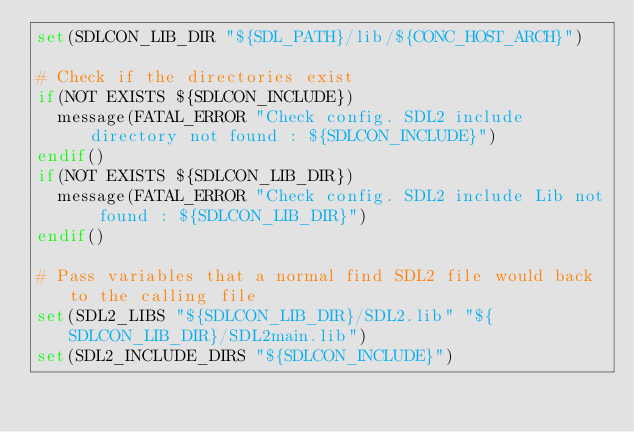Convert code to text. <code><loc_0><loc_0><loc_500><loc_500><_CMake_>set(SDLCON_LIB_DIR "${SDL_PATH}/lib/${CONC_HOST_ARCH}")

# Check if the directories exist
if(NOT EXISTS ${SDLCON_INCLUDE})
	message(FATAL_ERROR "Check config. SDL2 include directory not found : ${SDLCON_INCLUDE}")
endif()
if(NOT EXISTS ${SDLCON_LIB_DIR})
	message(FATAL_ERROR "Check config. SDL2 include Lib not found : ${SDLCON_LIB_DIR}")
endif()

# Pass variables that a normal find SDL2 file would back to the calling file
set(SDL2_LIBS "${SDLCON_LIB_DIR}/SDL2.lib" "${SDLCON_LIB_DIR}/SDL2main.lib")
set(SDL2_INCLUDE_DIRS "${SDLCON_INCLUDE}")</code> 